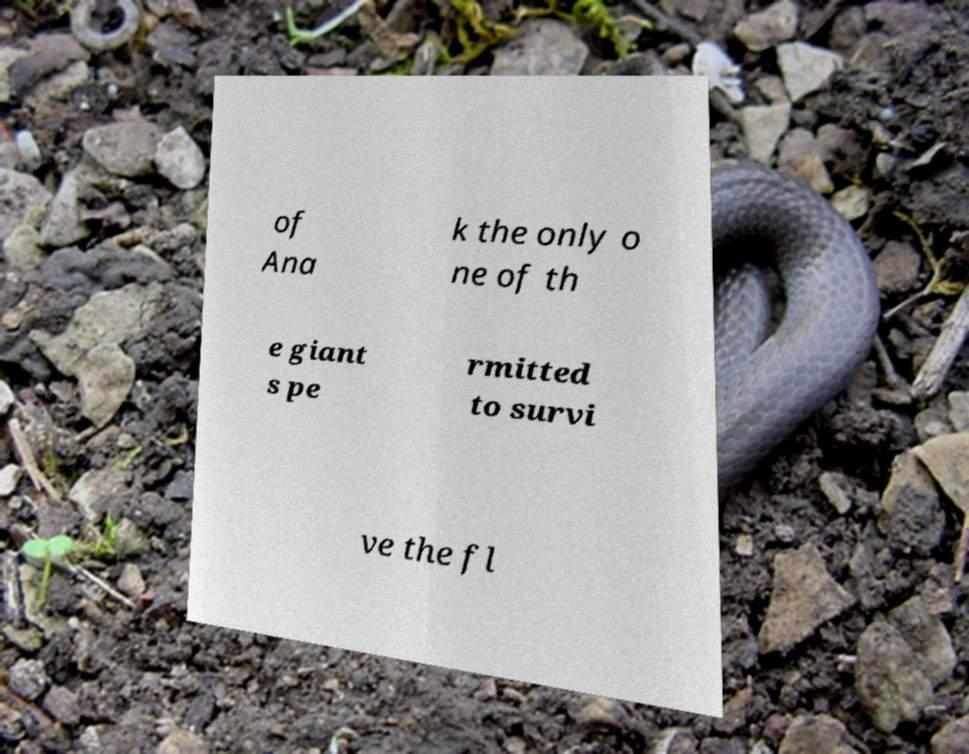Please identify and transcribe the text found in this image. of Ana k the only o ne of th e giant s pe rmitted to survi ve the fl 